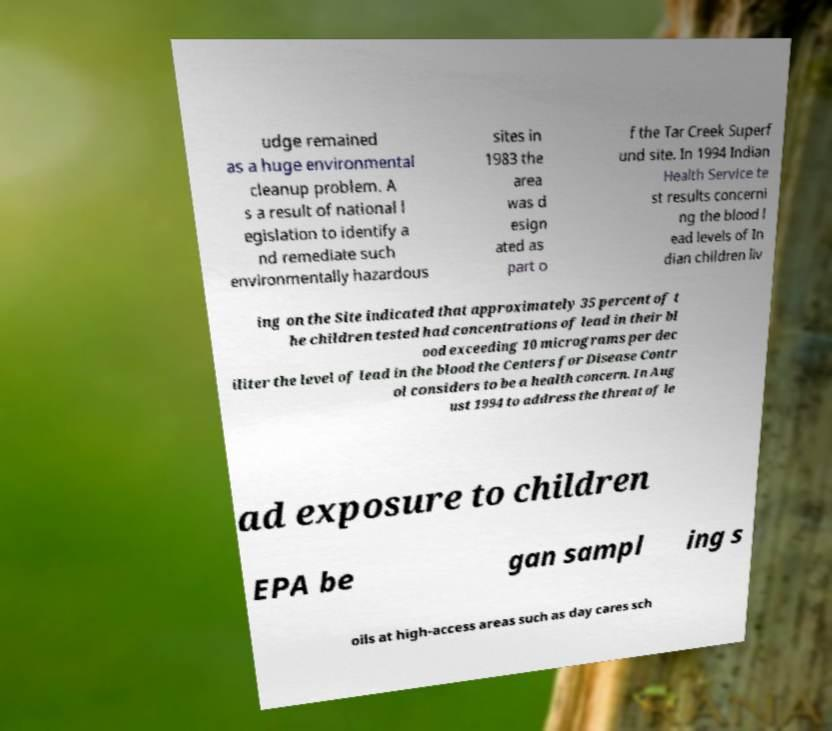Could you extract and type out the text from this image? udge remained as a huge environmental cleanup problem. A s a result of national l egislation to identify a nd remediate such environmentally hazardous sites in 1983 the area was d esign ated as part o f the Tar Creek Superf und site. In 1994 Indian Health Service te st results concerni ng the blood l ead levels of In dian children liv ing on the Site indicated that approximately 35 percent of t he children tested had concentrations of lead in their bl ood exceeding 10 micrograms per dec iliter the level of lead in the blood the Centers for Disease Contr ol considers to be a health concern. In Aug ust 1994 to address the threat of le ad exposure to children EPA be gan sampl ing s oils at high-access areas such as day cares sch 